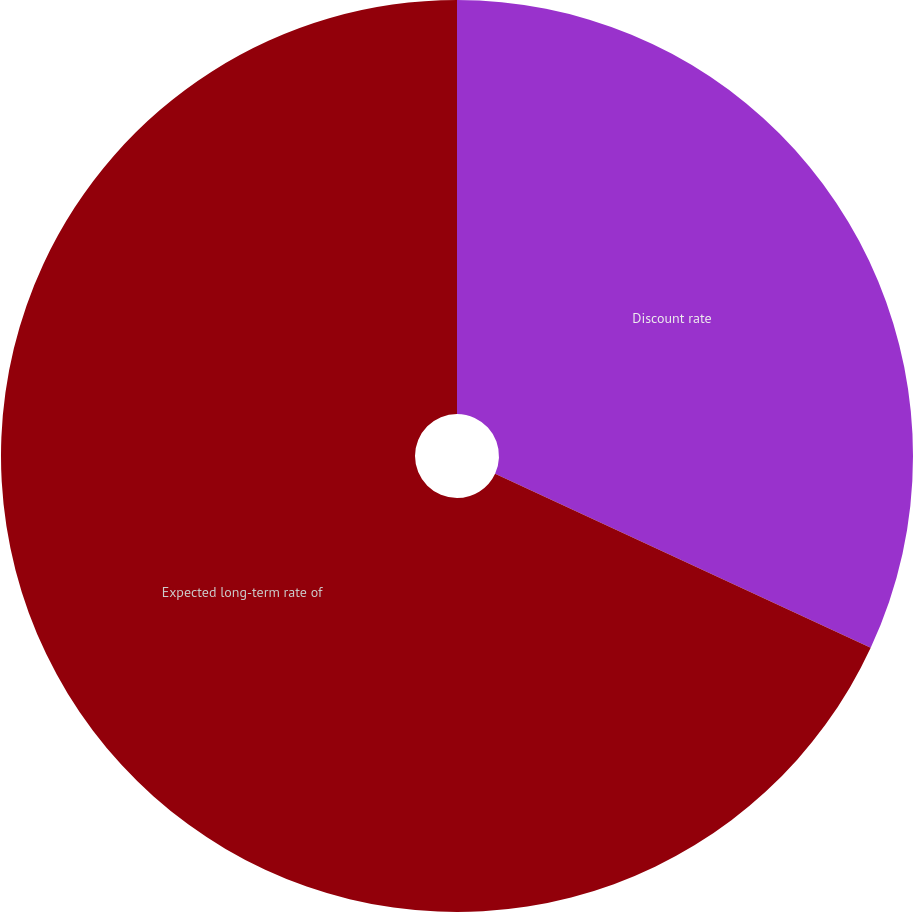Convert chart to OTSL. <chart><loc_0><loc_0><loc_500><loc_500><pie_chart><fcel>Discount rate<fcel>Expected long-term rate of<nl><fcel>31.91%<fcel>68.09%<nl></chart> 